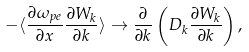<formula> <loc_0><loc_0><loc_500><loc_500>- \langle \frac { \partial \omega _ { p e } } { \partial x } \frac { \partial W _ { k } } { \partial k } \rangle \rightarrow \frac { \partial } { \partial k } \left ( D _ { k } \frac { \partial W _ { k } } { \partial k } \right ) ,</formula> 